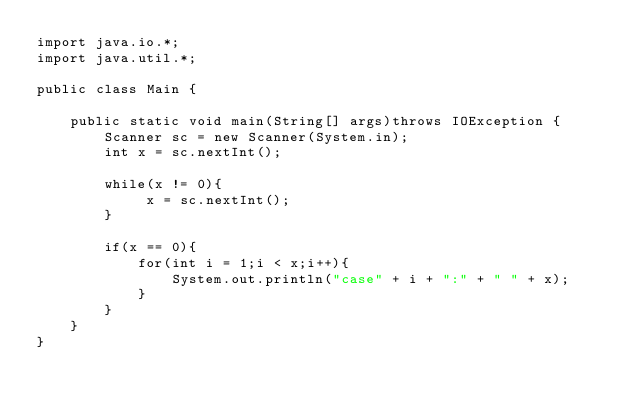Convert code to text. <code><loc_0><loc_0><loc_500><loc_500><_Java_>import java.io.*;
import java.util.*;

public class Main {

	public static void main(String[] args)throws IOException {
		Scanner sc = new Scanner(System.in);
		int x = sc.nextInt();
		
		while(x != 0){
			 x = sc.nextInt();
		}
		
		if(x == 0){
			for(int i = 1;i < x;i++){
				System.out.println("case" + i + ":" + " " + x);	
			}
		}
	}
}</code> 